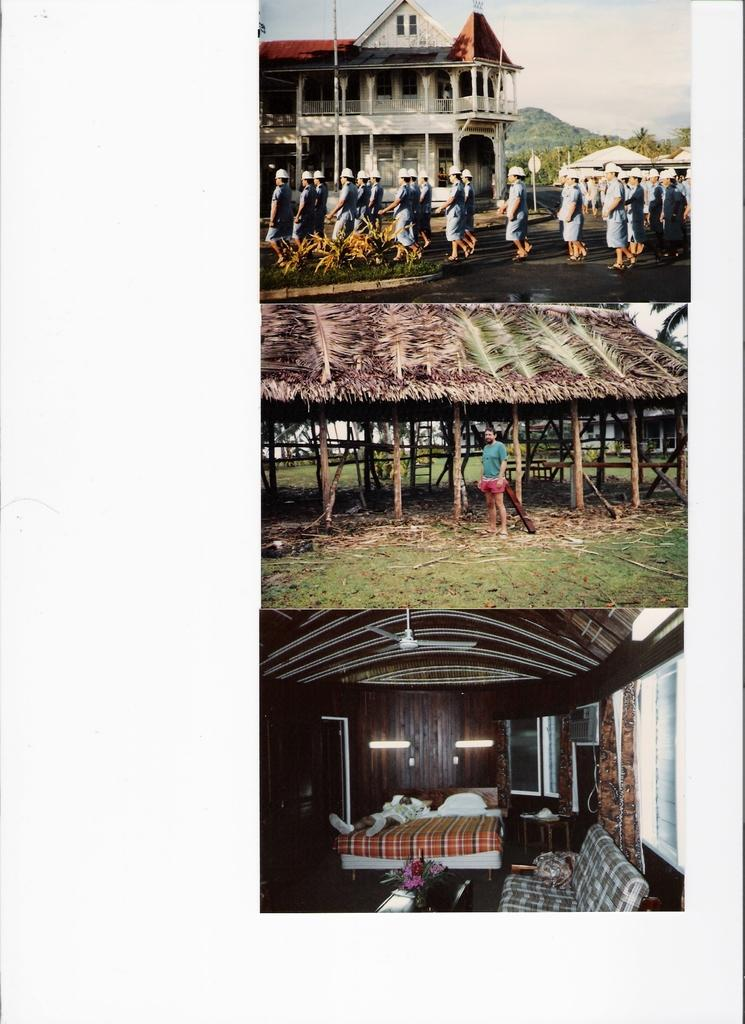What can be seen in the sky in the image? The sky is visible in the image, but no specific details about the sky are mentioned. What type of structure is present in the image? There is a building in the image. Who or what can be seen in the image besides the building? There is a group of persons, tents, trees, a shed, a ceiling fan, a bed, and a couch in the image. What type of attraction can be seen in the image? There is no attraction present in the image. Can you see any waves or fish in the image? There are no waves or fish present in the image. 